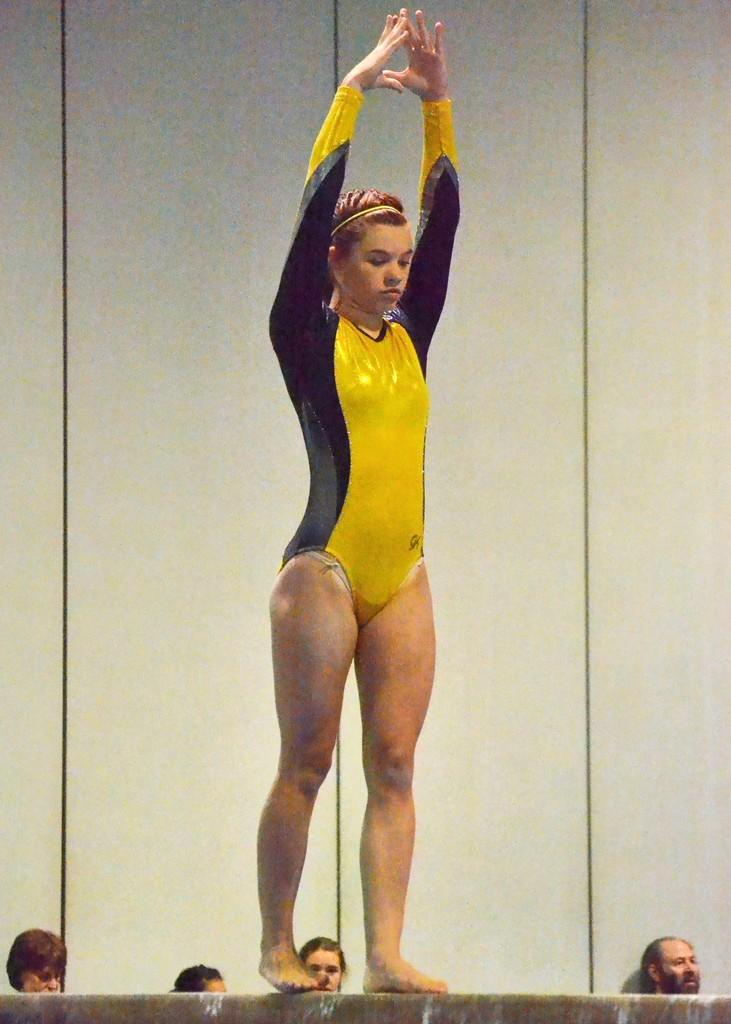Who is the main subject in the image? There is a woman in the image. What is the woman doing in the image? The woman is standing on a balancing beam. Can you describe the background of the image? There are people and a wall in the background of the image. How many babies are crawling on the balancing beam in the image? There are no babies present in the image, and the woman is standing on the balancing beam, not crawling. 